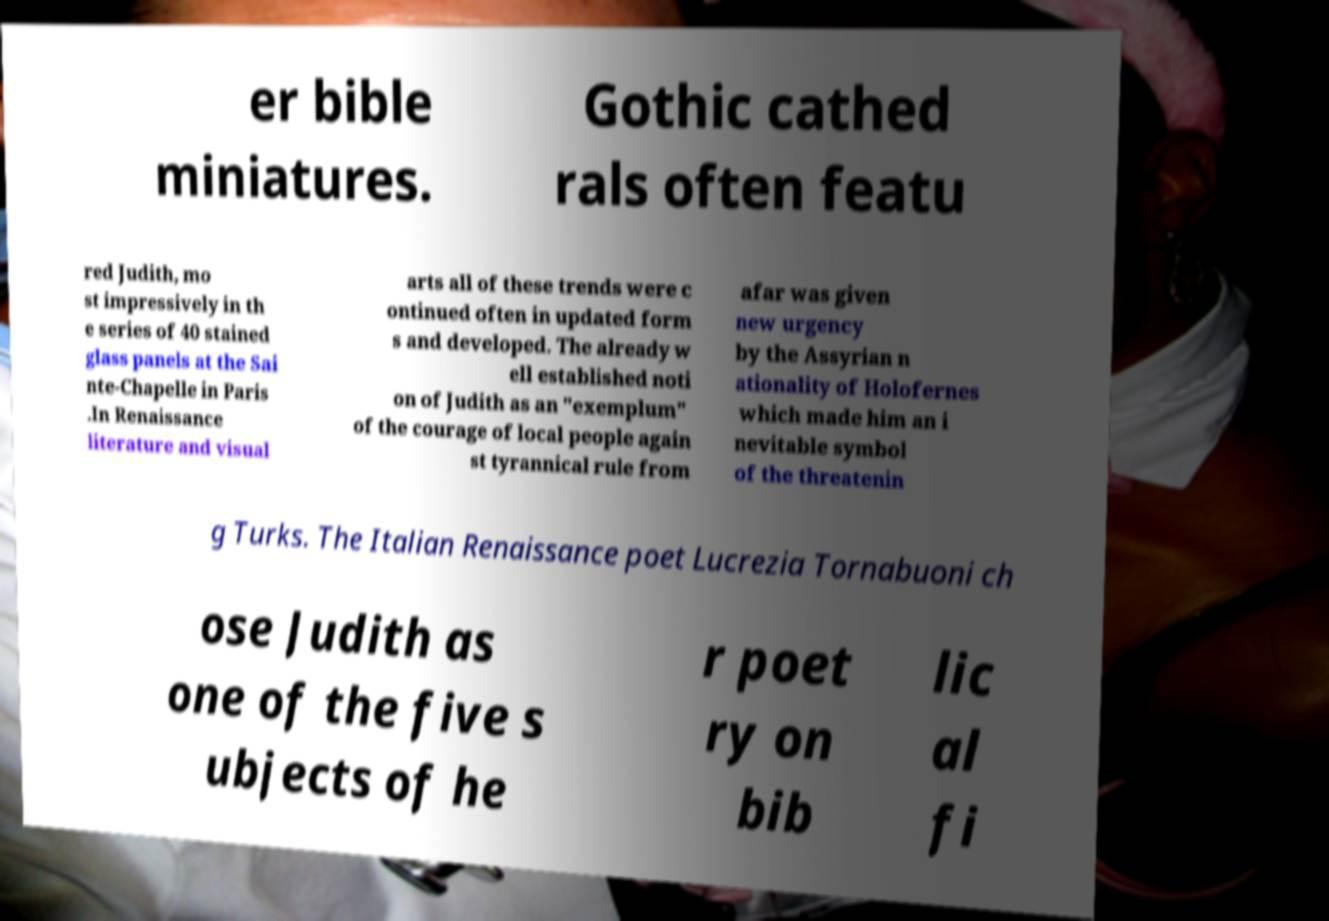What messages or text are displayed in this image? I need them in a readable, typed format. er bible miniatures. Gothic cathed rals often featu red Judith, mo st impressively in th e series of 40 stained glass panels at the Sai nte-Chapelle in Paris .In Renaissance literature and visual arts all of these trends were c ontinued often in updated form s and developed. The already w ell established noti on of Judith as an "exemplum" of the courage of local people again st tyrannical rule from afar was given new urgency by the Assyrian n ationality of Holofernes which made him an i nevitable symbol of the threatenin g Turks. The Italian Renaissance poet Lucrezia Tornabuoni ch ose Judith as one of the five s ubjects of he r poet ry on bib lic al fi 